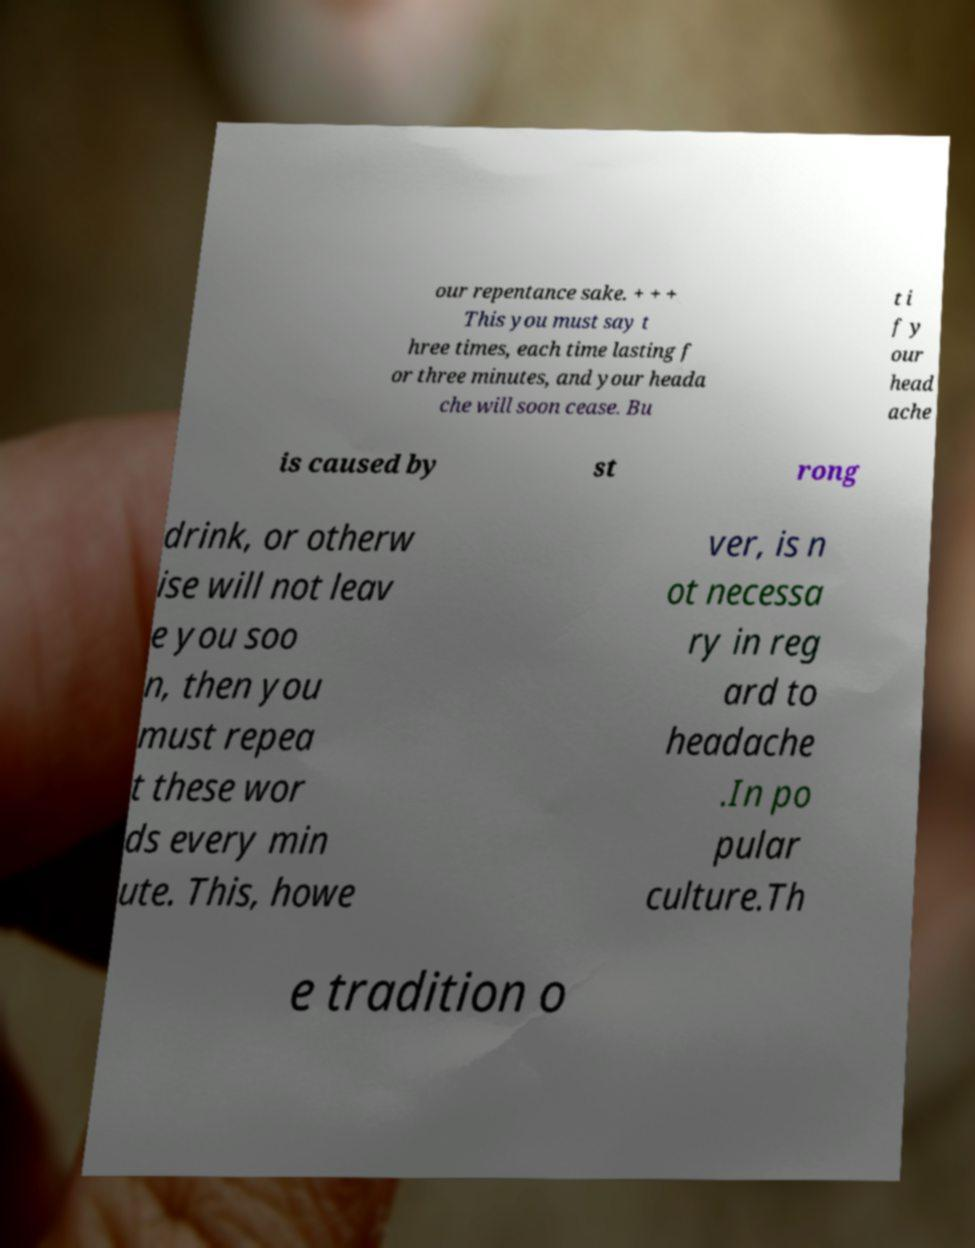Can you accurately transcribe the text from the provided image for me? our repentance sake. + + + This you must say t hree times, each time lasting f or three minutes, and your heada che will soon cease. Bu t i f y our head ache is caused by st rong drink, or otherw ise will not leav e you soo n, then you must repea t these wor ds every min ute. This, howe ver, is n ot necessa ry in reg ard to headache .In po pular culture.Th e tradition o 